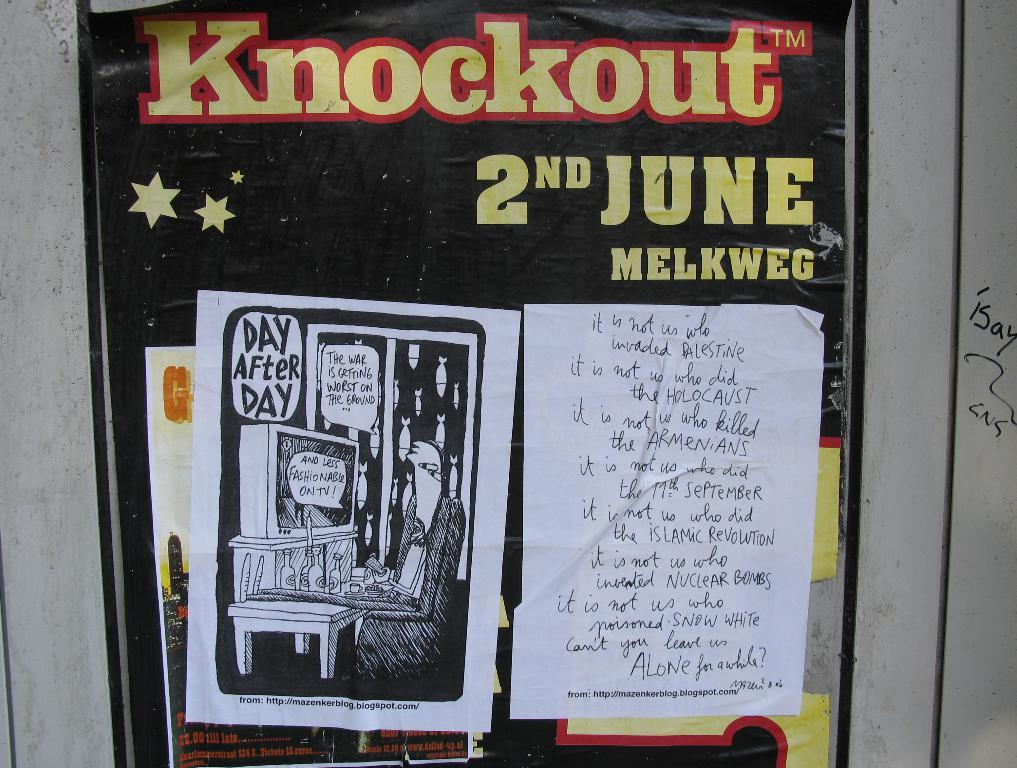<image>
Present a compact description of the photo's key features. A poster for Knockout which will be held on June 2nd. 